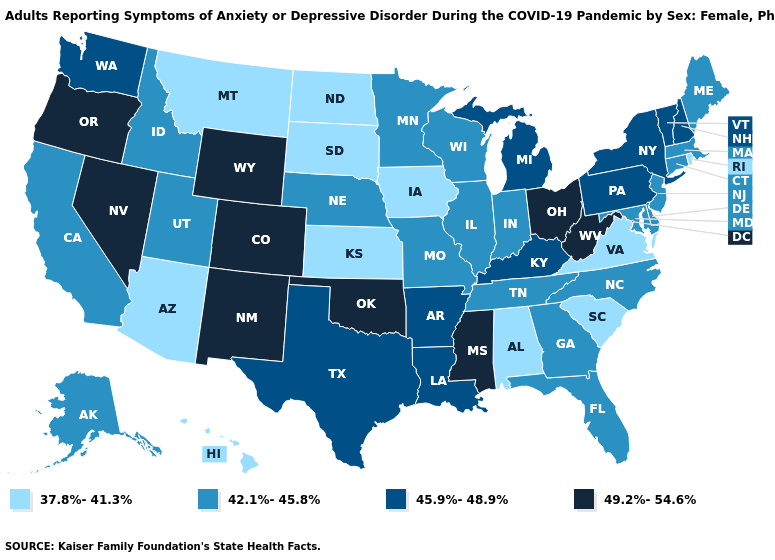Which states hav the highest value in the West?
Concise answer only. Colorado, Nevada, New Mexico, Oregon, Wyoming. Which states have the lowest value in the USA?
Keep it brief. Alabama, Arizona, Hawaii, Iowa, Kansas, Montana, North Dakota, Rhode Island, South Carolina, South Dakota, Virginia. What is the highest value in the Northeast ?
Quick response, please. 45.9%-48.9%. Among the states that border Delaware , does Pennsylvania have the lowest value?
Quick response, please. No. What is the value of Massachusetts?
Answer briefly. 42.1%-45.8%. Which states have the lowest value in the Northeast?
Keep it brief. Rhode Island. Among the states that border Pennsylvania , does Ohio have the lowest value?
Write a very short answer. No. Among the states that border Kansas , does Missouri have the lowest value?
Answer briefly. Yes. Does the map have missing data?
Concise answer only. No. Which states have the lowest value in the West?
Quick response, please. Arizona, Hawaii, Montana. Does the first symbol in the legend represent the smallest category?
Be succinct. Yes. Name the states that have a value in the range 45.9%-48.9%?
Quick response, please. Arkansas, Kentucky, Louisiana, Michigan, New Hampshire, New York, Pennsylvania, Texas, Vermont, Washington. Is the legend a continuous bar?
Short answer required. No. 